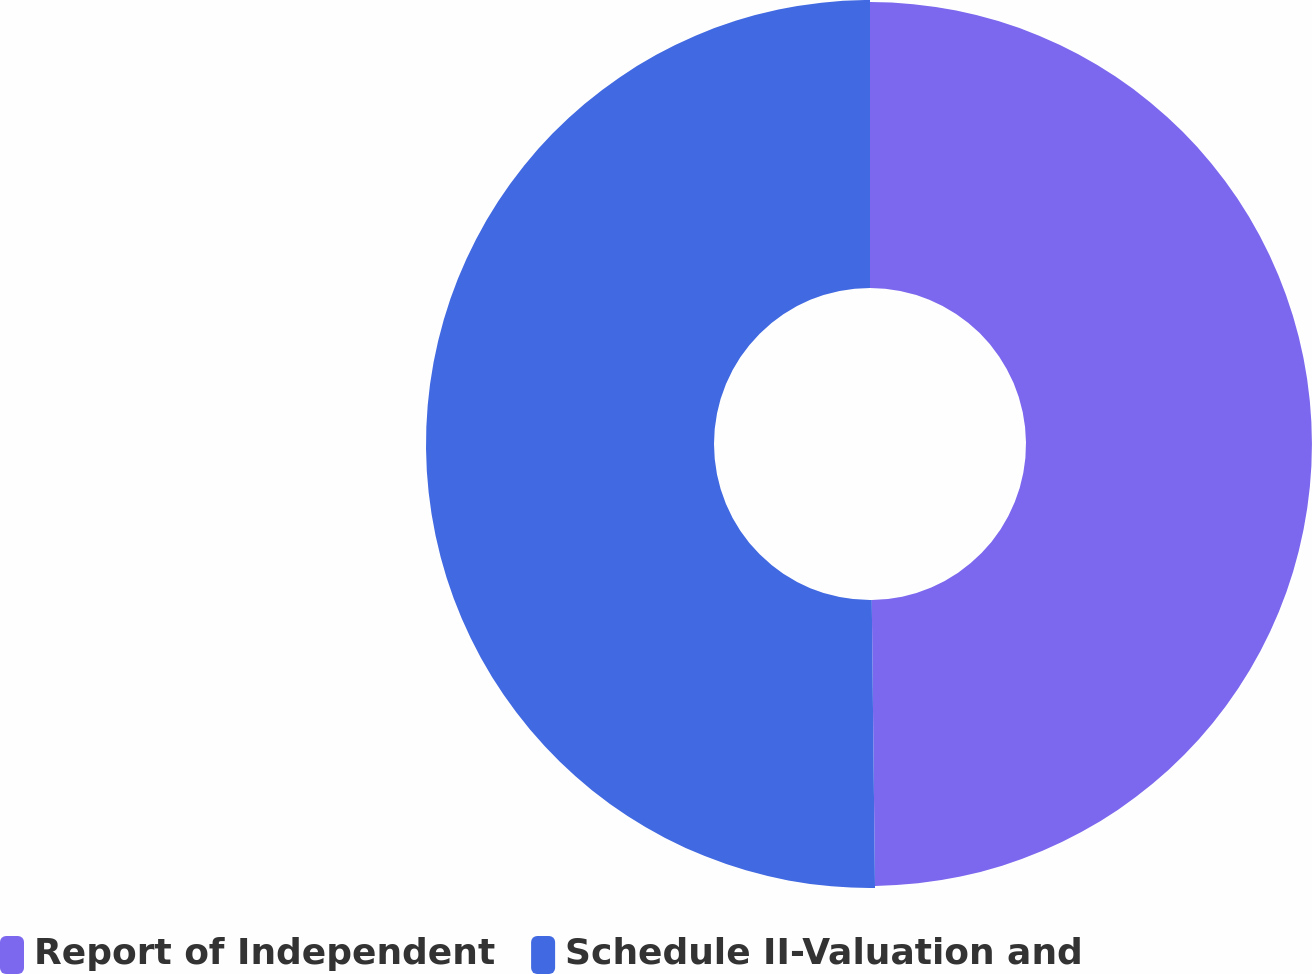<chart> <loc_0><loc_0><loc_500><loc_500><pie_chart><fcel>Report of Independent<fcel>Schedule II-Valuation and<nl><fcel>49.82%<fcel>50.18%<nl></chart> 